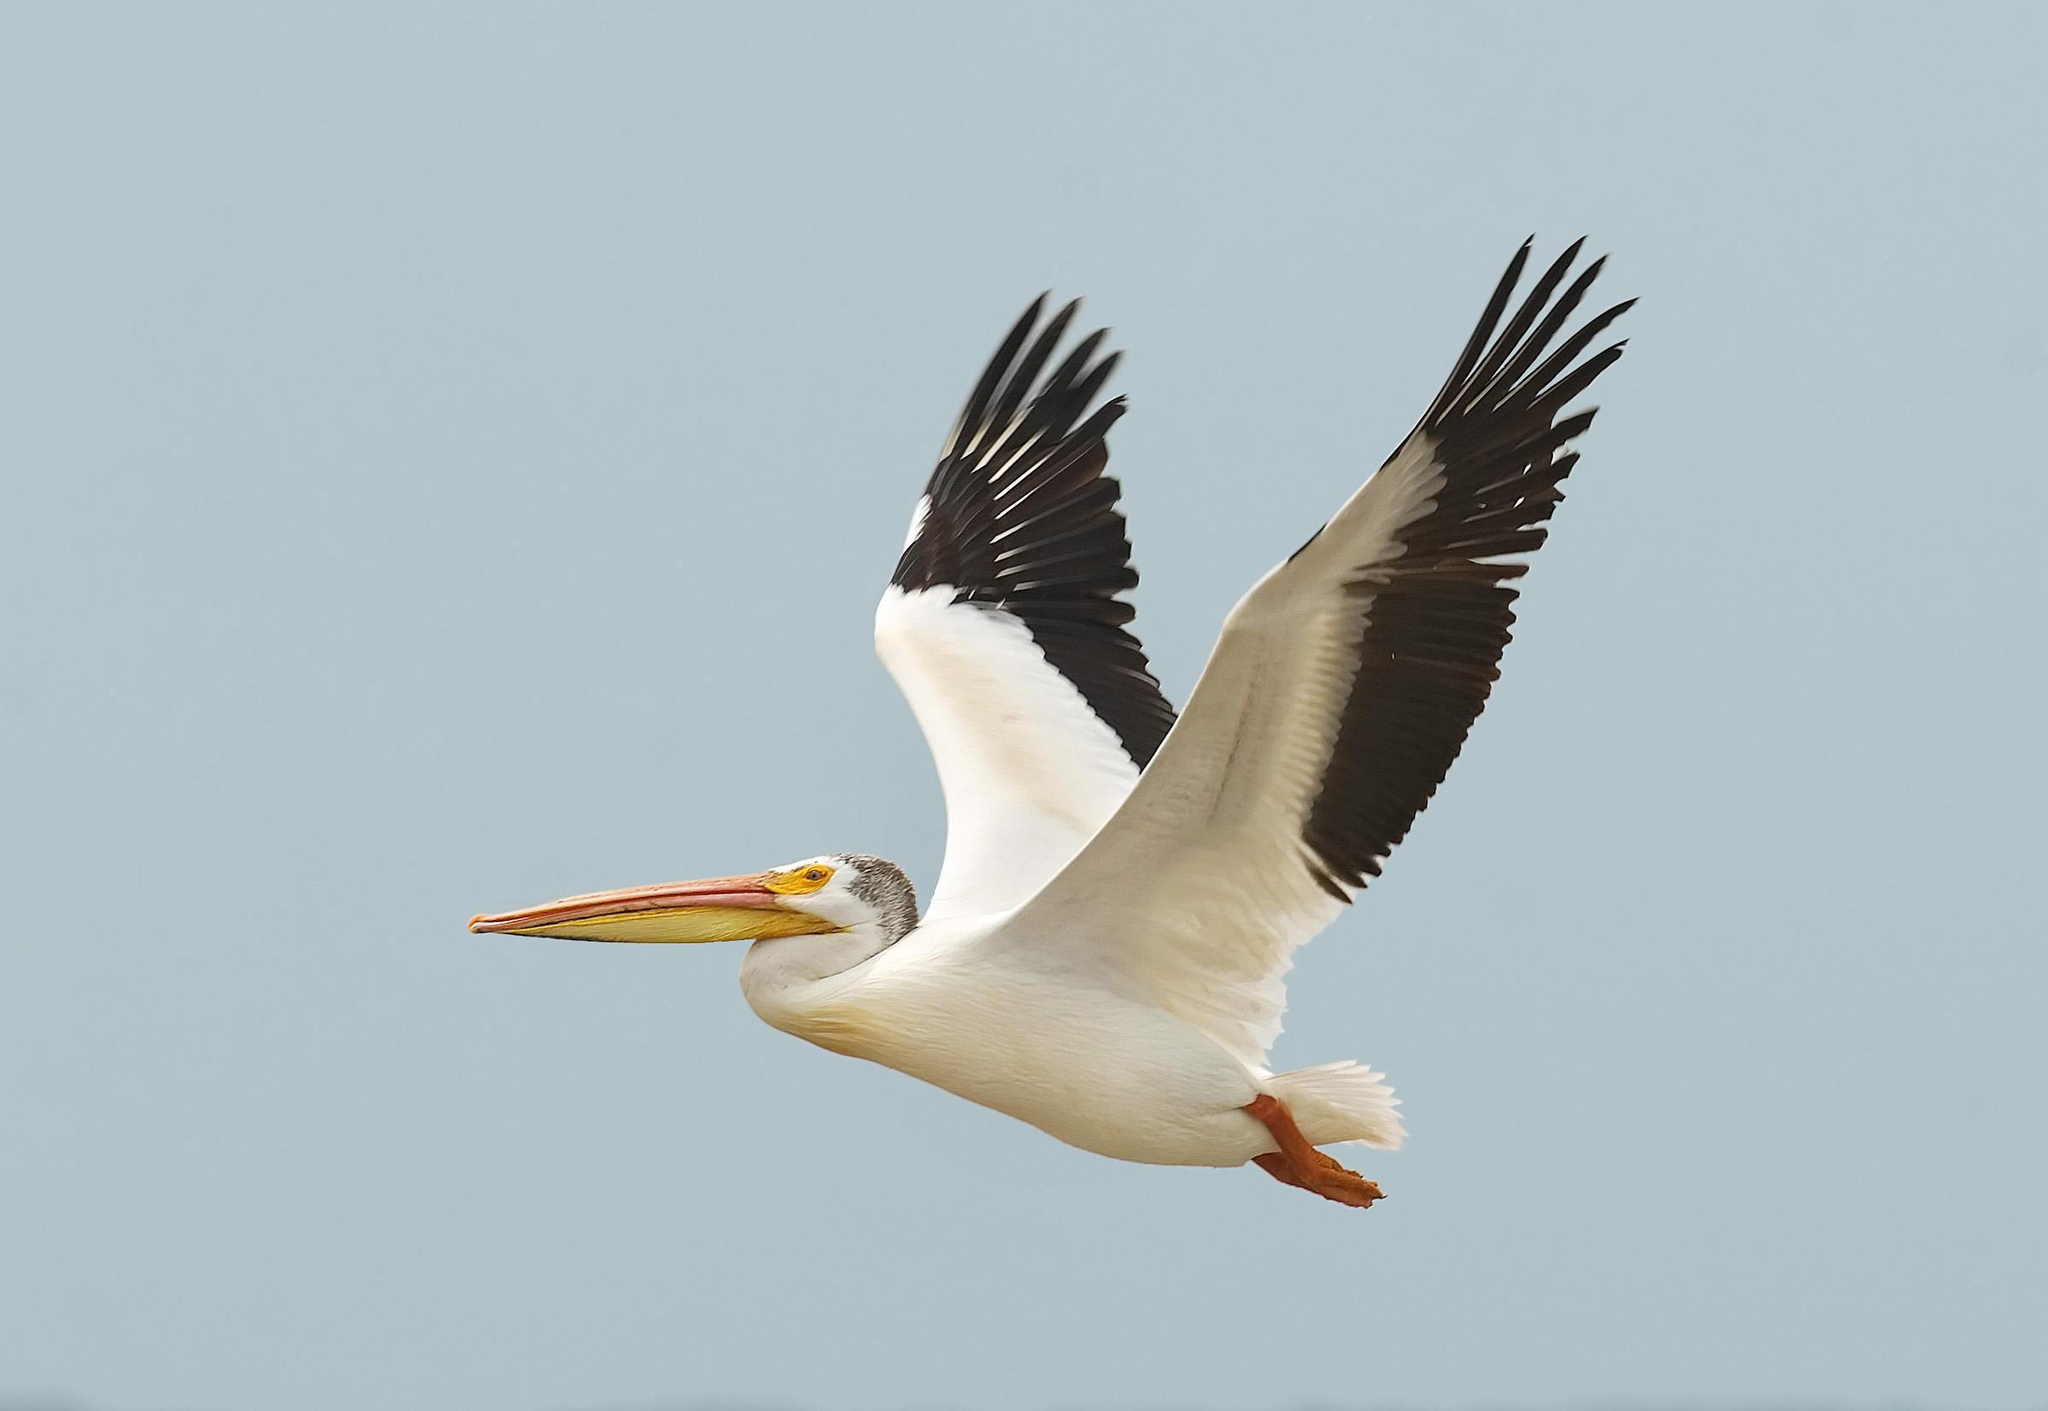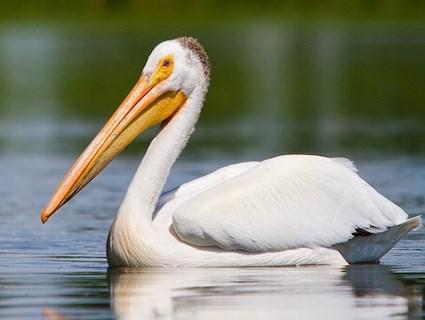The first image is the image on the left, the second image is the image on the right. Given the left and right images, does the statement "One long-beaked bird is floating on water, while a second is flying with wings stretched out showing the black feathery edges." hold true? Answer yes or no. Yes. The first image is the image on the left, the second image is the image on the right. For the images shown, is this caption "An image shows exactly two pelicans, including one that is in flight." true? Answer yes or no. No. 